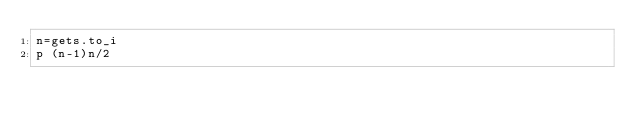Convert code to text. <code><loc_0><loc_0><loc_500><loc_500><_Ruby_>n=gets.to_i
p (n-1)n/2</code> 